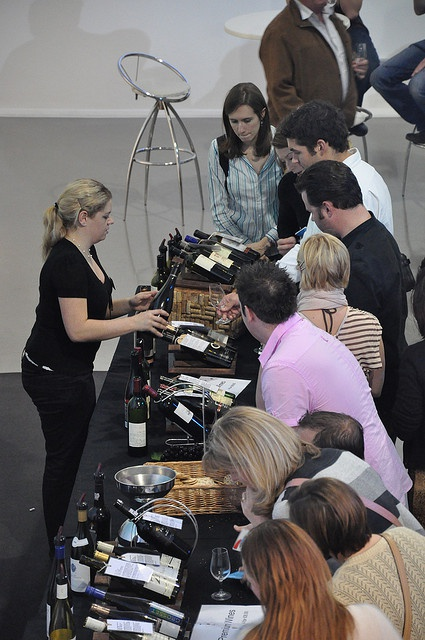Describe the objects in this image and their specific colors. I can see people in gray, black, and darkgray tones, people in gray, pink, black, lavender, and darkgray tones, people in gray, black, and tan tones, people in gray, darkgray, and black tones, and people in gray, brown, maroon, and black tones in this image. 